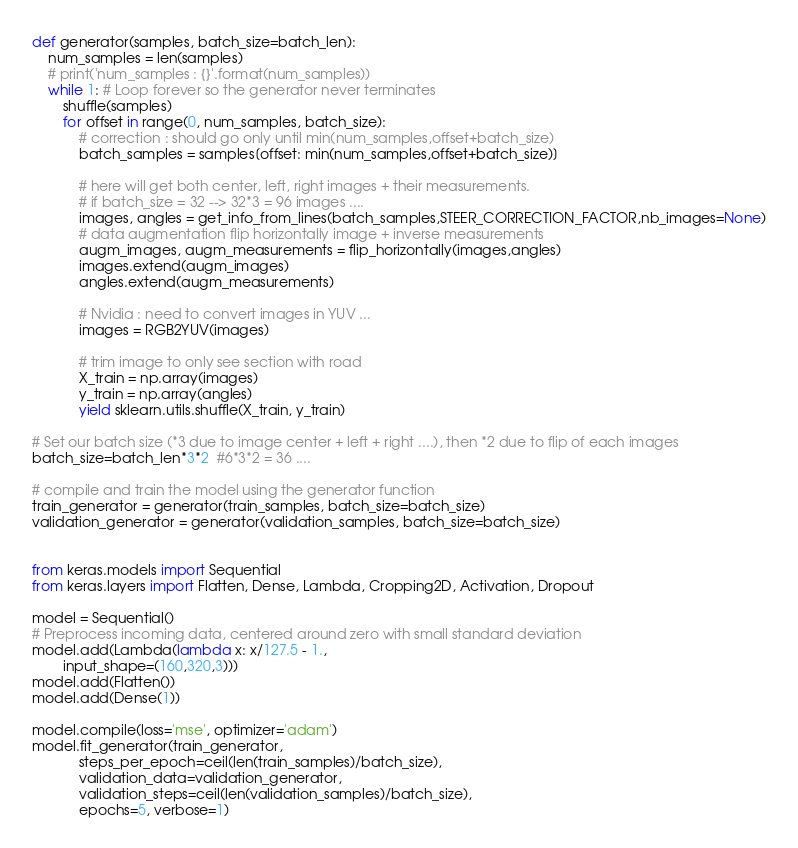Convert code to text. <code><loc_0><loc_0><loc_500><loc_500><_Python_>
def generator(samples, batch_size=batch_len):
    num_samples = len(samples)
    # print('num_samples : {}'.format(num_samples))
    while 1: # Loop forever so the generator never terminates
        shuffle(samples)
        for offset in range(0, num_samples, batch_size):
            # correction : should go only until min(num_samples,offset+batch_size)
            batch_samples = samples[offset: min(num_samples,offset+batch_size)]

            # here will get both center, left, right images + their measurements.
            # if batch_size = 32 --> 32*3 = 96 images ....
            images, angles = get_info_from_lines(batch_samples,STEER_CORRECTION_FACTOR,nb_images=None)
            # data augmentation flip horizontally image + inverse measurements
            augm_images, augm_measurements = flip_horizontally(images,angles)
            images.extend(augm_images)
            angles.extend(augm_measurements)
            
            # Nvidia : need to convert images in YUV ...
            images = RGB2YUV(images)
            
            # trim image to only see section with road
            X_train = np.array(images)
            y_train = np.array(angles)
            yield sklearn.utils.shuffle(X_train, y_train)

# Set our batch size (*3 due to image center + left + right ....), then *2 due to flip of each images
batch_size=batch_len*3*2  #6*3*2 = 36 ....

# compile and train the model using the generator function
train_generator = generator(train_samples, batch_size=batch_size)
validation_generator = generator(validation_samples, batch_size=batch_size)


from keras.models import Sequential
from keras.layers import Flatten, Dense, Lambda, Cropping2D, Activation, Dropout

model = Sequential()
# Preprocess incoming data, centered around zero with small standard deviation 
model.add(Lambda(lambda x: x/127.5 - 1.,
        input_shape=(160,320,3)))
model.add(Flatten())
model.add(Dense(1))

model.compile(loss='mse', optimizer='adam')
model.fit_generator(train_generator, 
            steps_per_epoch=ceil(len(train_samples)/batch_size), 
            validation_data=validation_generator, 
            validation_steps=ceil(len(validation_samples)/batch_size), 
            epochs=5, verbose=1)</code> 